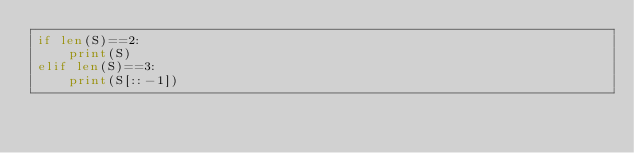<code> <loc_0><loc_0><loc_500><loc_500><_Python_>if len(S)==2:
    print(S)
elif len(S)==3:
    print(S[::-1])</code> 